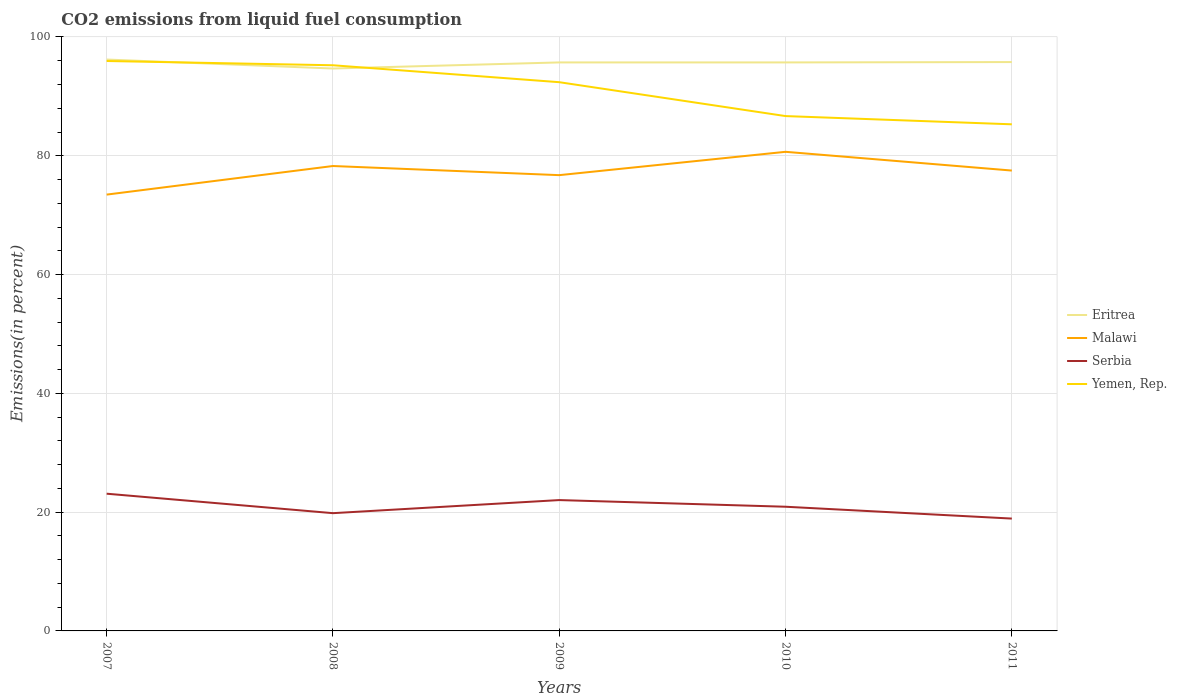How many different coloured lines are there?
Ensure brevity in your answer.  4. Is the number of lines equal to the number of legend labels?
Give a very brief answer. Yes. Across all years, what is the maximum total CO2 emitted in Serbia?
Make the answer very short. 18.91. What is the total total CO2 emitted in Malawi in the graph?
Your answer should be very brief. 3.16. What is the difference between the highest and the second highest total CO2 emitted in Eritrea?
Give a very brief answer. 1.51. What is the difference between the highest and the lowest total CO2 emitted in Serbia?
Your response must be concise. 2. How many lines are there?
Provide a short and direct response. 4. Does the graph contain any zero values?
Offer a terse response. No. How many legend labels are there?
Provide a short and direct response. 4. How are the legend labels stacked?
Your answer should be compact. Vertical. What is the title of the graph?
Make the answer very short. CO2 emissions from liquid fuel consumption. What is the label or title of the Y-axis?
Ensure brevity in your answer.  Emissions(in percent). What is the Emissions(in percent) of Eritrea in 2007?
Offer a terse response. 96.2. What is the Emissions(in percent) of Malawi in 2007?
Offer a very short reply. 73.46. What is the Emissions(in percent) of Serbia in 2007?
Keep it short and to the point. 23.1. What is the Emissions(in percent) in Yemen, Rep. in 2007?
Give a very brief answer. 95.95. What is the Emissions(in percent) of Eritrea in 2008?
Make the answer very short. 94.69. What is the Emissions(in percent) of Malawi in 2008?
Offer a terse response. 78.27. What is the Emissions(in percent) of Serbia in 2008?
Your answer should be compact. 19.83. What is the Emissions(in percent) in Yemen, Rep. in 2008?
Your answer should be very brief. 95.24. What is the Emissions(in percent) of Eritrea in 2009?
Keep it short and to the point. 95.71. What is the Emissions(in percent) in Malawi in 2009?
Provide a succinct answer. 76.74. What is the Emissions(in percent) of Serbia in 2009?
Provide a short and direct response. 22.03. What is the Emissions(in percent) in Yemen, Rep. in 2009?
Keep it short and to the point. 92.39. What is the Emissions(in percent) of Eritrea in 2010?
Your response must be concise. 95.71. What is the Emissions(in percent) in Malawi in 2010?
Your answer should be compact. 80.66. What is the Emissions(in percent) of Serbia in 2010?
Ensure brevity in your answer.  20.91. What is the Emissions(in percent) in Yemen, Rep. in 2010?
Keep it short and to the point. 86.68. What is the Emissions(in percent) in Eritrea in 2011?
Keep it short and to the point. 95.77. What is the Emissions(in percent) in Malawi in 2011?
Your response must be concise. 77.51. What is the Emissions(in percent) of Serbia in 2011?
Keep it short and to the point. 18.91. What is the Emissions(in percent) of Yemen, Rep. in 2011?
Your response must be concise. 85.3. Across all years, what is the maximum Emissions(in percent) of Eritrea?
Ensure brevity in your answer.  96.2. Across all years, what is the maximum Emissions(in percent) in Malawi?
Provide a short and direct response. 80.66. Across all years, what is the maximum Emissions(in percent) in Serbia?
Keep it short and to the point. 23.1. Across all years, what is the maximum Emissions(in percent) in Yemen, Rep.?
Your response must be concise. 95.95. Across all years, what is the minimum Emissions(in percent) in Eritrea?
Offer a very short reply. 94.69. Across all years, what is the minimum Emissions(in percent) in Malawi?
Your answer should be very brief. 73.46. Across all years, what is the minimum Emissions(in percent) of Serbia?
Make the answer very short. 18.91. Across all years, what is the minimum Emissions(in percent) of Yemen, Rep.?
Your answer should be very brief. 85.3. What is the total Emissions(in percent) of Eritrea in the graph?
Give a very brief answer. 478.1. What is the total Emissions(in percent) in Malawi in the graph?
Ensure brevity in your answer.  386.64. What is the total Emissions(in percent) in Serbia in the graph?
Your answer should be compact. 104.78. What is the total Emissions(in percent) in Yemen, Rep. in the graph?
Your answer should be very brief. 455.56. What is the difference between the Emissions(in percent) of Eritrea in 2007 and that in 2008?
Provide a succinct answer. 1.51. What is the difference between the Emissions(in percent) of Malawi in 2007 and that in 2008?
Your response must be concise. -4.81. What is the difference between the Emissions(in percent) of Serbia in 2007 and that in 2008?
Your answer should be compact. 3.28. What is the difference between the Emissions(in percent) in Yemen, Rep. in 2007 and that in 2008?
Give a very brief answer. 0.72. What is the difference between the Emissions(in percent) of Eritrea in 2007 and that in 2009?
Your answer should be very brief. 0.49. What is the difference between the Emissions(in percent) in Malawi in 2007 and that in 2009?
Your answer should be very brief. -3.27. What is the difference between the Emissions(in percent) of Serbia in 2007 and that in 2009?
Offer a very short reply. 1.07. What is the difference between the Emissions(in percent) in Yemen, Rep. in 2007 and that in 2009?
Make the answer very short. 3.57. What is the difference between the Emissions(in percent) in Eritrea in 2007 and that in 2010?
Provide a short and direct response. 0.49. What is the difference between the Emissions(in percent) in Malawi in 2007 and that in 2010?
Give a very brief answer. -7.2. What is the difference between the Emissions(in percent) in Serbia in 2007 and that in 2010?
Offer a very short reply. 2.19. What is the difference between the Emissions(in percent) in Yemen, Rep. in 2007 and that in 2010?
Ensure brevity in your answer.  9.27. What is the difference between the Emissions(in percent) in Eritrea in 2007 and that in 2011?
Ensure brevity in your answer.  0.43. What is the difference between the Emissions(in percent) of Malawi in 2007 and that in 2011?
Offer a terse response. -4.05. What is the difference between the Emissions(in percent) in Serbia in 2007 and that in 2011?
Your answer should be compact. 4.19. What is the difference between the Emissions(in percent) in Yemen, Rep. in 2007 and that in 2011?
Provide a short and direct response. 10.66. What is the difference between the Emissions(in percent) in Eritrea in 2008 and that in 2009?
Provide a short and direct response. -1.02. What is the difference between the Emissions(in percent) of Malawi in 2008 and that in 2009?
Keep it short and to the point. 1.54. What is the difference between the Emissions(in percent) of Serbia in 2008 and that in 2009?
Provide a short and direct response. -2.2. What is the difference between the Emissions(in percent) in Yemen, Rep. in 2008 and that in 2009?
Offer a very short reply. 2.85. What is the difference between the Emissions(in percent) in Eritrea in 2008 and that in 2010?
Ensure brevity in your answer.  -1.02. What is the difference between the Emissions(in percent) of Malawi in 2008 and that in 2010?
Your response must be concise. -2.39. What is the difference between the Emissions(in percent) of Serbia in 2008 and that in 2010?
Your answer should be very brief. -1.08. What is the difference between the Emissions(in percent) in Yemen, Rep. in 2008 and that in 2010?
Provide a short and direct response. 8.56. What is the difference between the Emissions(in percent) in Eritrea in 2008 and that in 2011?
Keep it short and to the point. -1.08. What is the difference between the Emissions(in percent) in Malawi in 2008 and that in 2011?
Ensure brevity in your answer.  0.77. What is the difference between the Emissions(in percent) in Serbia in 2008 and that in 2011?
Your answer should be compact. 0.91. What is the difference between the Emissions(in percent) of Yemen, Rep. in 2008 and that in 2011?
Offer a terse response. 9.94. What is the difference between the Emissions(in percent) of Eritrea in 2009 and that in 2010?
Ensure brevity in your answer.  0. What is the difference between the Emissions(in percent) in Malawi in 2009 and that in 2010?
Make the answer very short. -3.93. What is the difference between the Emissions(in percent) in Serbia in 2009 and that in 2010?
Your response must be concise. 1.12. What is the difference between the Emissions(in percent) of Yemen, Rep. in 2009 and that in 2010?
Keep it short and to the point. 5.71. What is the difference between the Emissions(in percent) of Eritrea in 2009 and that in 2011?
Provide a short and direct response. -0.06. What is the difference between the Emissions(in percent) in Malawi in 2009 and that in 2011?
Ensure brevity in your answer.  -0.77. What is the difference between the Emissions(in percent) in Serbia in 2009 and that in 2011?
Ensure brevity in your answer.  3.11. What is the difference between the Emissions(in percent) of Yemen, Rep. in 2009 and that in 2011?
Provide a succinct answer. 7.09. What is the difference between the Emissions(in percent) in Eritrea in 2010 and that in 2011?
Your answer should be compact. -0.06. What is the difference between the Emissions(in percent) in Malawi in 2010 and that in 2011?
Offer a very short reply. 3.16. What is the difference between the Emissions(in percent) of Serbia in 2010 and that in 2011?
Provide a succinct answer. 2. What is the difference between the Emissions(in percent) of Yemen, Rep. in 2010 and that in 2011?
Ensure brevity in your answer.  1.39. What is the difference between the Emissions(in percent) in Eritrea in 2007 and the Emissions(in percent) in Malawi in 2008?
Make the answer very short. 17.93. What is the difference between the Emissions(in percent) in Eritrea in 2007 and the Emissions(in percent) in Serbia in 2008?
Offer a very short reply. 76.38. What is the difference between the Emissions(in percent) of Eritrea in 2007 and the Emissions(in percent) of Yemen, Rep. in 2008?
Your answer should be compact. 0.97. What is the difference between the Emissions(in percent) in Malawi in 2007 and the Emissions(in percent) in Serbia in 2008?
Offer a terse response. 53.64. What is the difference between the Emissions(in percent) in Malawi in 2007 and the Emissions(in percent) in Yemen, Rep. in 2008?
Give a very brief answer. -21.78. What is the difference between the Emissions(in percent) of Serbia in 2007 and the Emissions(in percent) of Yemen, Rep. in 2008?
Offer a very short reply. -72.13. What is the difference between the Emissions(in percent) of Eritrea in 2007 and the Emissions(in percent) of Malawi in 2009?
Make the answer very short. 19.47. What is the difference between the Emissions(in percent) in Eritrea in 2007 and the Emissions(in percent) in Serbia in 2009?
Provide a succinct answer. 74.17. What is the difference between the Emissions(in percent) of Eritrea in 2007 and the Emissions(in percent) of Yemen, Rep. in 2009?
Your response must be concise. 3.81. What is the difference between the Emissions(in percent) in Malawi in 2007 and the Emissions(in percent) in Serbia in 2009?
Make the answer very short. 51.43. What is the difference between the Emissions(in percent) in Malawi in 2007 and the Emissions(in percent) in Yemen, Rep. in 2009?
Provide a succinct answer. -18.93. What is the difference between the Emissions(in percent) of Serbia in 2007 and the Emissions(in percent) of Yemen, Rep. in 2009?
Your response must be concise. -69.28. What is the difference between the Emissions(in percent) in Eritrea in 2007 and the Emissions(in percent) in Malawi in 2010?
Make the answer very short. 15.54. What is the difference between the Emissions(in percent) in Eritrea in 2007 and the Emissions(in percent) in Serbia in 2010?
Provide a short and direct response. 75.29. What is the difference between the Emissions(in percent) of Eritrea in 2007 and the Emissions(in percent) of Yemen, Rep. in 2010?
Make the answer very short. 9.52. What is the difference between the Emissions(in percent) of Malawi in 2007 and the Emissions(in percent) of Serbia in 2010?
Your answer should be very brief. 52.55. What is the difference between the Emissions(in percent) in Malawi in 2007 and the Emissions(in percent) in Yemen, Rep. in 2010?
Your answer should be very brief. -13.22. What is the difference between the Emissions(in percent) in Serbia in 2007 and the Emissions(in percent) in Yemen, Rep. in 2010?
Your answer should be compact. -63.58. What is the difference between the Emissions(in percent) of Eritrea in 2007 and the Emissions(in percent) of Malawi in 2011?
Your answer should be very brief. 18.69. What is the difference between the Emissions(in percent) of Eritrea in 2007 and the Emissions(in percent) of Serbia in 2011?
Your answer should be compact. 77.29. What is the difference between the Emissions(in percent) in Eritrea in 2007 and the Emissions(in percent) in Yemen, Rep. in 2011?
Provide a succinct answer. 10.91. What is the difference between the Emissions(in percent) of Malawi in 2007 and the Emissions(in percent) of Serbia in 2011?
Your answer should be very brief. 54.55. What is the difference between the Emissions(in percent) in Malawi in 2007 and the Emissions(in percent) in Yemen, Rep. in 2011?
Keep it short and to the point. -11.83. What is the difference between the Emissions(in percent) of Serbia in 2007 and the Emissions(in percent) of Yemen, Rep. in 2011?
Give a very brief answer. -62.19. What is the difference between the Emissions(in percent) of Eritrea in 2008 and the Emissions(in percent) of Malawi in 2009?
Give a very brief answer. 17.95. What is the difference between the Emissions(in percent) in Eritrea in 2008 and the Emissions(in percent) in Serbia in 2009?
Your answer should be very brief. 72.66. What is the difference between the Emissions(in percent) of Eritrea in 2008 and the Emissions(in percent) of Yemen, Rep. in 2009?
Offer a terse response. 2.3. What is the difference between the Emissions(in percent) in Malawi in 2008 and the Emissions(in percent) in Serbia in 2009?
Make the answer very short. 56.25. What is the difference between the Emissions(in percent) in Malawi in 2008 and the Emissions(in percent) in Yemen, Rep. in 2009?
Ensure brevity in your answer.  -14.11. What is the difference between the Emissions(in percent) in Serbia in 2008 and the Emissions(in percent) in Yemen, Rep. in 2009?
Make the answer very short. -72.56. What is the difference between the Emissions(in percent) in Eritrea in 2008 and the Emissions(in percent) in Malawi in 2010?
Keep it short and to the point. 14.03. What is the difference between the Emissions(in percent) in Eritrea in 2008 and the Emissions(in percent) in Serbia in 2010?
Give a very brief answer. 73.78. What is the difference between the Emissions(in percent) of Eritrea in 2008 and the Emissions(in percent) of Yemen, Rep. in 2010?
Your answer should be very brief. 8.01. What is the difference between the Emissions(in percent) of Malawi in 2008 and the Emissions(in percent) of Serbia in 2010?
Your answer should be very brief. 57.37. What is the difference between the Emissions(in percent) of Malawi in 2008 and the Emissions(in percent) of Yemen, Rep. in 2010?
Provide a short and direct response. -8.41. What is the difference between the Emissions(in percent) of Serbia in 2008 and the Emissions(in percent) of Yemen, Rep. in 2010?
Provide a short and direct response. -66.86. What is the difference between the Emissions(in percent) in Eritrea in 2008 and the Emissions(in percent) in Malawi in 2011?
Your answer should be compact. 17.18. What is the difference between the Emissions(in percent) in Eritrea in 2008 and the Emissions(in percent) in Serbia in 2011?
Your response must be concise. 75.78. What is the difference between the Emissions(in percent) in Eritrea in 2008 and the Emissions(in percent) in Yemen, Rep. in 2011?
Make the answer very short. 9.39. What is the difference between the Emissions(in percent) in Malawi in 2008 and the Emissions(in percent) in Serbia in 2011?
Offer a very short reply. 59.36. What is the difference between the Emissions(in percent) in Malawi in 2008 and the Emissions(in percent) in Yemen, Rep. in 2011?
Provide a short and direct response. -7.02. What is the difference between the Emissions(in percent) in Serbia in 2008 and the Emissions(in percent) in Yemen, Rep. in 2011?
Your response must be concise. -65.47. What is the difference between the Emissions(in percent) in Eritrea in 2009 and the Emissions(in percent) in Malawi in 2010?
Your answer should be compact. 15.05. What is the difference between the Emissions(in percent) of Eritrea in 2009 and the Emissions(in percent) of Serbia in 2010?
Your answer should be very brief. 74.8. What is the difference between the Emissions(in percent) in Eritrea in 2009 and the Emissions(in percent) in Yemen, Rep. in 2010?
Keep it short and to the point. 9.03. What is the difference between the Emissions(in percent) in Malawi in 2009 and the Emissions(in percent) in Serbia in 2010?
Your answer should be very brief. 55.83. What is the difference between the Emissions(in percent) of Malawi in 2009 and the Emissions(in percent) of Yemen, Rep. in 2010?
Offer a terse response. -9.95. What is the difference between the Emissions(in percent) in Serbia in 2009 and the Emissions(in percent) in Yemen, Rep. in 2010?
Ensure brevity in your answer.  -64.65. What is the difference between the Emissions(in percent) in Eritrea in 2009 and the Emissions(in percent) in Malawi in 2011?
Provide a succinct answer. 18.21. What is the difference between the Emissions(in percent) in Eritrea in 2009 and the Emissions(in percent) in Serbia in 2011?
Keep it short and to the point. 76.8. What is the difference between the Emissions(in percent) of Eritrea in 2009 and the Emissions(in percent) of Yemen, Rep. in 2011?
Your answer should be compact. 10.42. What is the difference between the Emissions(in percent) of Malawi in 2009 and the Emissions(in percent) of Serbia in 2011?
Offer a terse response. 57.82. What is the difference between the Emissions(in percent) in Malawi in 2009 and the Emissions(in percent) in Yemen, Rep. in 2011?
Your answer should be compact. -8.56. What is the difference between the Emissions(in percent) in Serbia in 2009 and the Emissions(in percent) in Yemen, Rep. in 2011?
Your answer should be compact. -63.27. What is the difference between the Emissions(in percent) of Eritrea in 2010 and the Emissions(in percent) of Malawi in 2011?
Provide a short and direct response. 18.21. What is the difference between the Emissions(in percent) of Eritrea in 2010 and the Emissions(in percent) of Serbia in 2011?
Your answer should be very brief. 76.8. What is the difference between the Emissions(in percent) of Eritrea in 2010 and the Emissions(in percent) of Yemen, Rep. in 2011?
Keep it short and to the point. 10.42. What is the difference between the Emissions(in percent) of Malawi in 2010 and the Emissions(in percent) of Serbia in 2011?
Your answer should be compact. 61.75. What is the difference between the Emissions(in percent) in Malawi in 2010 and the Emissions(in percent) in Yemen, Rep. in 2011?
Provide a succinct answer. -4.63. What is the difference between the Emissions(in percent) of Serbia in 2010 and the Emissions(in percent) of Yemen, Rep. in 2011?
Your response must be concise. -64.39. What is the average Emissions(in percent) in Eritrea per year?
Offer a terse response. 95.62. What is the average Emissions(in percent) in Malawi per year?
Ensure brevity in your answer.  77.33. What is the average Emissions(in percent) of Serbia per year?
Ensure brevity in your answer.  20.96. What is the average Emissions(in percent) of Yemen, Rep. per year?
Offer a terse response. 91.11. In the year 2007, what is the difference between the Emissions(in percent) in Eritrea and Emissions(in percent) in Malawi?
Make the answer very short. 22.74. In the year 2007, what is the difference between the Emissions(in percent) of Eritrea and Emissions(in percent) of Serbia?
Your answer should be compact. 73.1. In the year 2007, what is the difference between the Emissions(in percent) of Eritrea and Emissions(in percent) of Yemen, Rep.?
Give a very brief answer. 0.25. In the year 2007, what is the difference between the Emissions(in percent) of Malawi and Emissions(in percent) of Serbia?
Provide a short and direct response. 50.36. In the year 2007, what is the difference between the Emissions(in percent) in Malawi and Emissions(in percent) in Yemen, Rep.?
Provide a succinct answer. -22.49. In the year 2007, what is the difference between the Emissions(in percent) in Serbia and Emissions(in percent) in Yemen, Rep.?
Provide a short and direct response. -72.85. In the year 2008, what is the difference between the Emissions(in percent) of Eritrea and Emissions(in percent) of Malawi?
Your answer should be very brief. 16.42. In the year 2008, what is the difference between the Emissions(in percent) of Eritrea and Emissions(in percent) of Serbia?
Keep it short and to the point. 74.86. In the year 2008, what is the difference between the Emissions(in percent) of Eritrea and Emissions(in percent) of Yemen, Rep.?
Keep it short and to the point. -0.55. In the year 2008, what is the difference between the Emissions(in percent) in Malawi and Emissions(in percent) in Serbia?
Provide a short and direct response. 58.45. In the year 2008, what is the difference between the Emissions(in percent) of Malawi and Emissions(in percent) of Yemen, Rep.?
Your answer should be compact. -16.96. In the year 2008, what is the difference between the Emissions(in percent) in Serbia and Emissions(in percent) in Yemen, Rep.?
Provide a succinct answer. -75.41. In the year 2009, what is the difference between the Emissions(in percent) of Eritrea and Emissions(in percent) of Malawi?
Offer a terse response. 18.98. In the year 2009, what is the difference between the Emissions(in percent) in Eritrea and Emissions(in percent) in Serbia?
Keep it short and to the point. 73.69. In the year 2009, what is the difference between the Emissions(in percent) in Eritrea and Emissions(in percent) in Yemen, Rep.?
Your answer should be very brief. 3.33. In the year 2009, what is the difference between the Emissions(in percent) in Malawi and Emissions(in percent) in Serbia?
Offer a terse response. 54.71. In the year 2009, what is the difference between the Emissions(in percent) of Malawi and Emissions(in percent) of Yemen, Rep.?
Provide a succinct answer. -15.65. In the year 2009, what is the difference between the Emissions(in percent) in Serbia and Emissions(in percent) in Yemen, Rep.?
Provide a short and direct response. -70.36. In the year 2010, what is the difference between the Emissions(in percent) in Eritrea and Emissions(in percent) in Malawi?
Give a very brief answer. 15.05. In the year 2010, what is the difference between the Emissions(in percent) in Eritrea and Emissions(in percent) in Serbia?
Provide a short and direct response. 74.8. In the year 2010, what is the difference between the Emissions(in percent) in Eritrea and Emissions(in percent) in Yemen, Rep.?
Give a very brief answer. 9.03. In the year 2010, what is the difference between the Emissions(in percent) in Malawi and Emissions(in percent) in Serbia?
Keep it short and to the point. 59.76. In the year 2010, what is the difference between the Emissions(in percent) of Malawi and Emissions(in percent) of Yemen, Rep.?
Offer a very short reply. -6.02. In the year 2010, what is the difference between the Emissions(in percent) of Serbia and Emissions(in percent) of Yemen, Rep.?
Your answer should be compact. -65.77. In the year 2011, what is the difference between the Emissions(in percent) of Eritrea and Emissions(in percent) of Malawi?
Keep it short and to the point. 18.27. In the year 2011, what is the difference between the Emissions(in percent) in Eritrea and Emissions(in percent) in Serbia?
Offer a terse response. 76.86. In the year 2011, what is the difference between the Emissions(in percent) in Eritrea and Emissions(in percent) in Yemen, Rep.?
Keep it short and to the point. 10.48. In the year 2011, what is the difference between the Emissions(in percent) in Malawi and Emissions(in percent) in Serbia?
Provide a short and direct response. 58.59. In the year 2011, what is the difference between the Emissions(in percent) of Malawi and Emissions(in percent) of Yemen, Rep.?
Provide a succinct answer. -7.79. In the year 2011, what is the difference between the Emissions(in percent) of Serbia and Emissions(in percent) of Yemen, Rep.?
Your response must be concise. -66.38. What is the ratio of the Emissions(in percent) of Eritrea in 2007 to that in 2008?
Your answer should be very brief. 1.02. What is the ratio of the Emissions(in percent) in Malawi in 2007 to that in 2008?
Your answer should be compact. 0.94. What is the ratio of the Emissions(in percent) of Serbia in 2007 to that in 2008?
Offer a very short reply. 1.17. What is the ratio of the Emissions(in percent) in Yemen, Rep. in 2007 to that in 2008?
Keep it short and to the point. 1.01. What is the ratio of the Emissions(in percent) in Malawi in 2007 to that in 2009?
Your answer should be very brief. 0.96. What is the ratio of the Emissions(in percent) of Serbia in 2007 to that in 2009?
Give a very brief answer. 1.05. What is the ratio of the Emissions(in percent) in Yemen, Rep. in 2007 to that in 2009?
Provide a short and direct response. 1.04. What is the ratio of the Emissions(in percent) in Malawi in 2007 to that in 2010?
Make the answer very short. 0.91. What is the ratio of the Emissions(in percent) of Serbia in 2007 to that in 2010?
Ensure brevity in your answer.  1.1. What is the ratio of the Emissions(in percent) of Yemen, Rep. in 2007 to that in 2010?
Ensure brevity in your answer.  1.11. What is the ratio of the Emissions(in percent) in Malawi in 2007 to that in 2011?
Your answer should be very brief. 0.95. What is the ratio of the Emissions(in percent) of Serbia in 2007 to that in 2011?
Make the answer very short. 1.22. What is the ratio of the Emissions(in percent) of Eritrea in 2008 to that in 2009?
Offer a very short reply. 0.99. What is the ratio of the Emissions(in percent) of Malawi in 2008 to that in 2009?
Provide a succinct answer. 1.02. What is the ratio of the Emissions(in percent) of Yemen, Rep. in 2008 to that in 2009?
Provide a short and direct response. 1.03. What is the ratio of the Emissions(in percent) in Eritrea in 2008 to that in 2010?
Keep it short and to the point. 0.99. What is the ratio of the Emissions(in percent) of Malawi in 2008 to that in 2010?
Make the answer very short. 0.97. What is the ratio of the Emissions(in percent) of Serbia in 2008 to that in 2010?
Your answer should be very brief. 0.95. What is the ratio of the Emissions(in percent) in Yemen, Rep. in 2008 to that in 2010?
Offer a very short reply. 1.1. What is the ratio of the Emissions(in percent) in Eritrea in 2008 to that in 2011?
Provide a short and direct response. 0.99. What is the ratio of the Emissions(in percent) of Malawi in 2008 to that in 2011?
Your answer should be very brief. 1.01. What is the ratio of the Emissions(in percent) in Serbia in 2008 to that in 2011?
Give a very brief answer. 1.05. What is the ratio of the Emissions(in percent) in Yemen, Rep. in 2008 to that in 2011?
Your answer should be very brief. 1.12. What is the ratio of the Emissions(in percent) of Eritrea in 2009 to that in 2010?
Your answer should be very brief. 1. What is the ratio of the Emissions(in percent) of Malawi in 2009 to that in 2010?
Give a very brief answer. 0.95. What is the ratio of the Emissions(in percent) of Serbia in 2009 to that in 2010?
Your answer should be compact. 1.05. What is the ratio of the Emissions(in percent) of Yemen, Rep. in 2009 to that in 2010?
Your response must be concise. 1.07. What is the ratio of the Emissions(in percent) of Eritrea in 2009 to that in 2011?
Keep it short and to the point. 1. What is the ratio of the Emissions(in percent) of Malawi in 2009 to that in 2011?
Keep it short and to the point. 0.99. What is the ratio of the Emissions(in percent) of Serbia in 2009 to that in 2011?
Offer a terse response. 1.16. What is the ratio of the Emissions(in percent) of Yemen, Rep. in 2009 to that in 2011?
Give a very brief answer. 1.08. What is the ratio of the Emissions(in percent) of Eritrea in 2010 to that in 2011?
Your answer should be very brief. 1. What is the ratio of the Emissions(in percent) of Malawi in 2010 to that in 2011?
Provide a succinct answer. 1.04. What is the ratio of the Emissions(in percent) in Serbia in 2010 to that in 2011?
Provide a short and direct response. 1.11. What is the ratio of the Emissions(in percent) in Yemen, Rep. in 2010 to that in 2011?
Provide a succinct answer. 1.02. What is the difference between the highest and the second highest Emissions(in percent) in Eritrea?
Your answer should be very brief. 0.43. What is the difference between the highest and the second highest Emissions(in percent) of Malawi?
Your answer should be compact. 2.39. What is the difference between the highest and the second highest Emissions(in percent) of Serbia?
Provide a succinct answer. 1.07. What is the difference between the highest and the second highest Emissions(in percent) in Yemen, Rep.?
Offer a terse response. 0.72. What is the difference between the highest and the lowest Emissions(in percent) of Eritrea?
Your answer should be compact. 1.51. What is the difference between the highest and the lowest Emissions(in percent) in Malawi?
Make the answer very short. 7.2. What is the difference between the highest and the lowest Emissions(in percent) of Serbia?
Provide a short and direct response. 4.19. What is the difference between the highest and the lowest Emissions(in percent) in Yemen, Rep.?
Your response must be concise. 10.66. 